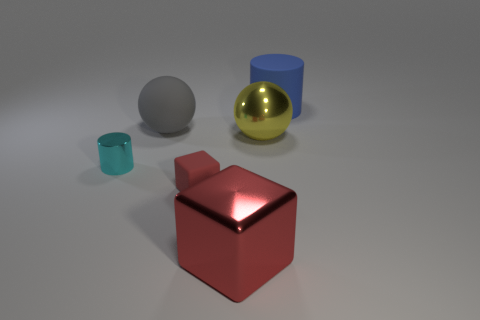The thing that is the same color as the large metallic block is what size?
Provide a short and direct response. Small. Is there a cyan object of the same shape as the red shiny object?
Offer a very short reply. No. Are there fewer blue things that are in front of the cyan metallic cylinder than big gray rubber objects?
Your response must be concise. Yes. Do the big blue object and the small cyan metal object have the same shape?
Your answer should be compact. Yes. How big is the cylinder that is on the right side of the small cyan cylinder?
Provide a short and direct response. Large. What size is the cylinder that is the same material as the large gray ball?
Offer a terse response. Large. Are there fewer small brown cylinders than shiny cylinders?
Ensure brevity in your answer.  Yes. There is a blue object that is the same size as the gray object; what material is it?
Your answer should be compact. Rubber. Are there more gray rubber objects than big purple things?
Your answer should be very brief. Yes. How many other things are the same color as the metallic block?
Give a very brief answer. 1. 